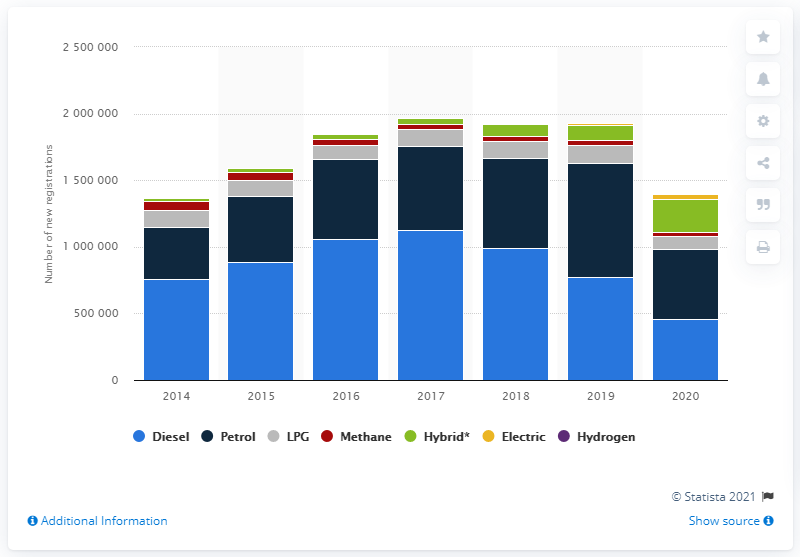Outline some significant characteristics in this image. In 2018, passenger car sales in Italy decreased for the first time since 2014. 